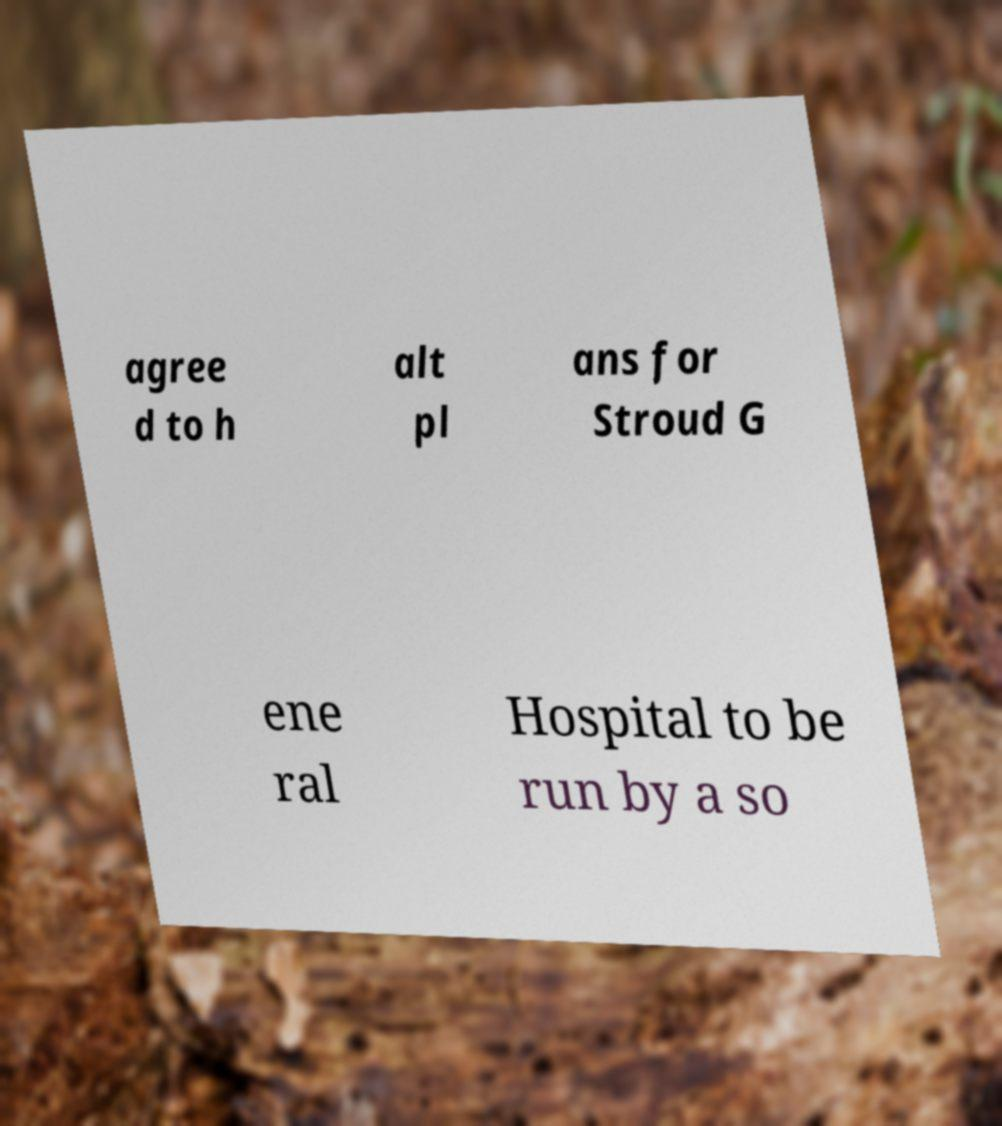Could you extract and type out the text from this image? agree d to h alt pl ans for Stroud G ene ral Hospital to be run by a so 